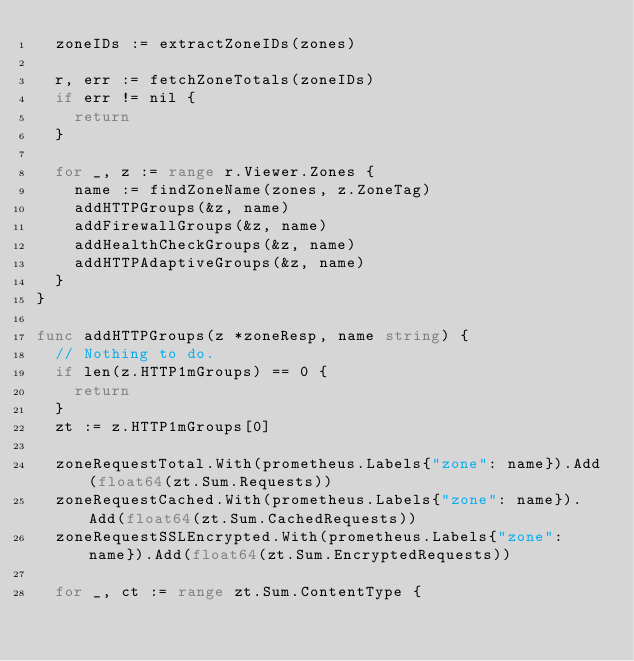Convert code to text. <code><loc_0><loc_0><loc_500><loc_500><_Go_>	zoneIDs := extractZoneIDs(zones)

	r, err := fetchZoneTotals(zoneIDs)
	if err != nil {
		return
	}

	for _, z := range r.Viewer.Zones {
		name := findZoneName(zones, z.ZoneTag)
		addHTTPGroups(&z, name)
		addFirewallGroups(&z, name)
		addHealthCheckGroups(&z, name)
		addHTTPAdaptiveGroups(&z, name)
	}
}

func addHTTPGroups(z *zoneResp, name string) {
	// Nothing to do.
	if len(z.HTTP1mGroups) == 0 {
		return
	}
	zt := z.HTTP1mGroups[0]

	zoneRequestTotal.With(prometheus.Labels{"zone": name}).Add(float64(zt.Sum.Requests))
	zoneRequestCached.With(prometheus.Labels{"zone": name}).Add(float64(zt.Sum.CachedRequests))
	zoneRequestSSLEncrypted.With(prometheus.Labels{"zone": name}).Add(float64(zt.Sum.EncryptedRequests))

	for _, ct := range zt.Sum.ContentType {</code> 